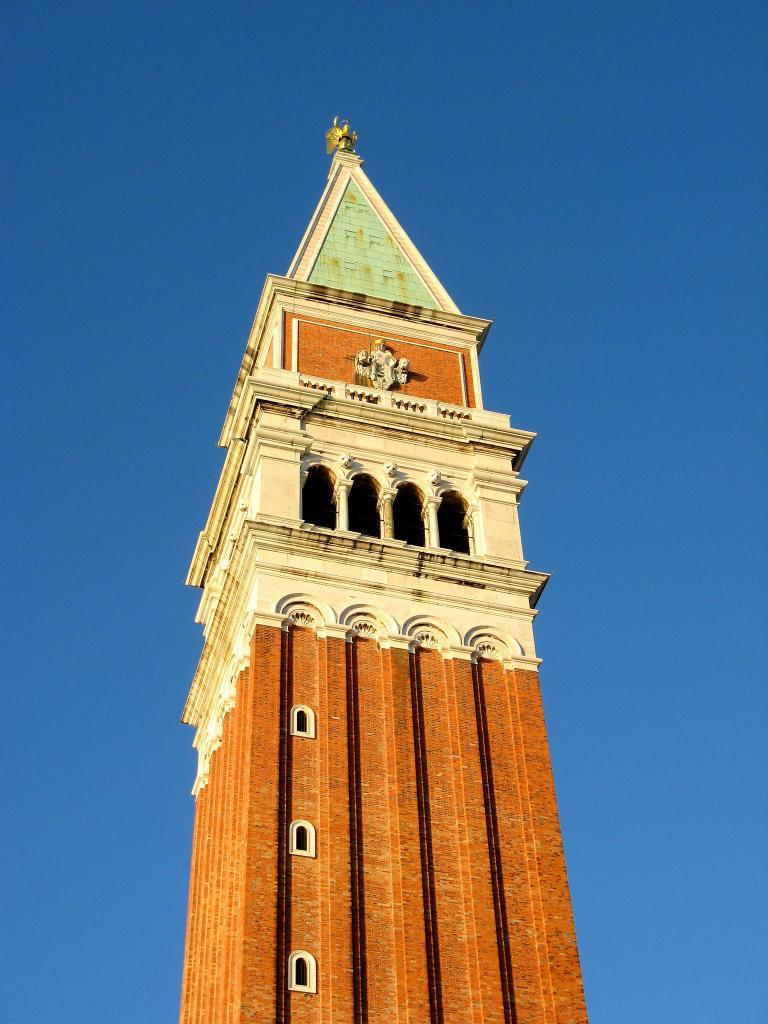What structure is the main subject of the image? There is a bell tower in the image. What colors are used to depict the bell tower? The bell tower is in white and brown color. What can be seen in the background of the image? The sky is visible in the background of the image. What is the color of the sky in the image? The sky is blue in color. What type of smell can be detected coming from the bell tower in the image? There is no indication of any smell in the image, as it is a visual representation of a bell tower and the surrounding sky. 